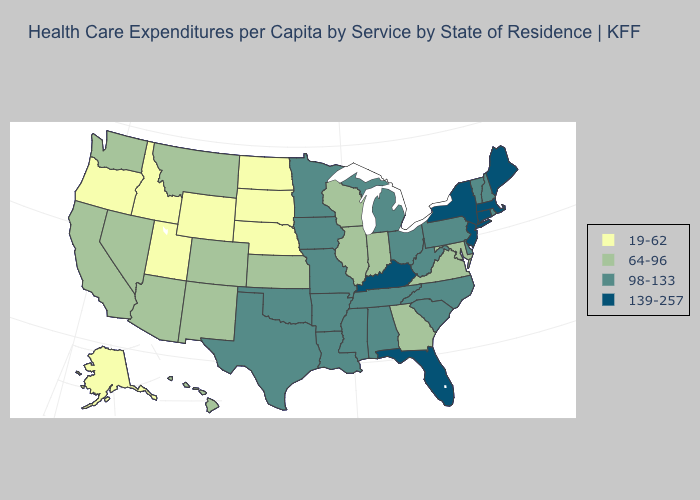Name the states that have a value in the range 64-96?
Short answer required. Arizona, California, Colorado, Georgia, Hawaii, Illinois, Indiana, Kansas, Maryland, Montana, Nevada, New Mexico, Virginia, Washington, Wisconsin. Which states have the lowest value in the USA?
Be succinct. Alaska, Idaho, Nebraska, North Dakota, Oregon, South Dakota, Utah, Wyoming. What is the value of Arizona?
Answer briefly. 64-96. What is the lowest value in states that border Wisconsin?
Give a very brief answer. 64-96. Does Kentucky have the lowest value in the USA?
Concise answer only. No. Does Oregon have a lower value than Mississippi?
Keep it brief. Yes. What is the value of Arizona?
Be succinct. 64-96. Does Florida have the highest value in the South?
Answer briefly. Yes. What is the lowest value in states that border Colorado?
Give a very brief answer. 19-62. Which states have the highest value in the USA?
Give a very brief answer. Connecticut, Florida, Kentucky, Maine, Massachusetts, New Jersey, New York. Does Montana have the same value as West Virginia?
Be succinct. No. What is the value of New Mexico?
Answer briefly. 64-96. What is the value of Wisconsin?
Short answer required. 64-96. Which states hav the highest value in the MidWest?
Give a very brief answer. Iowa, Michigan, Minnesota, Missouri, Ohio. Which states have the lowest value in the MidWest?
Short answer required. Nebraska, North Dakota, South Dakota. 